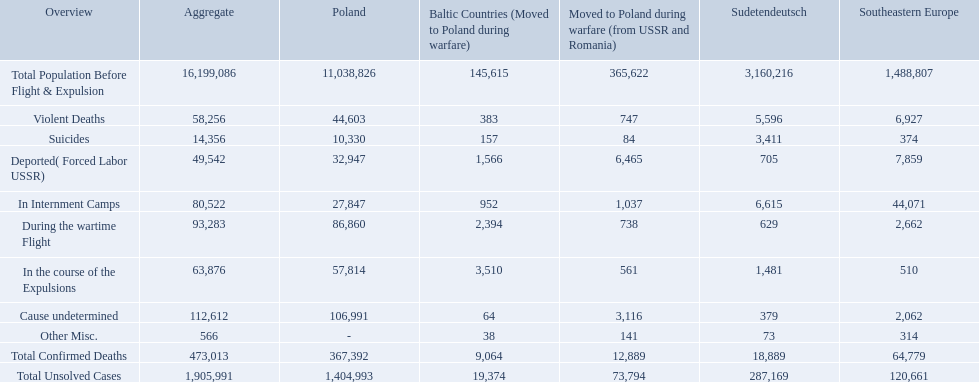What are the numbers of violent deaths across the area? 44,603, 383, 747, 5,596, 6,927. What is the total number of violent deaths of the area? 58,256. How many deaths did the baltic states have in each category? 145,615, 383, 157, 1,566, 952, 2,394, 3,510, 64, 38, 9,064, 19,374. How many cause undetermined deaths did baltic states have? 64. How many other miscellaneous deaths did baltic states have? 38. Which is higher in deaths, cause undetermined or other miscellaneous? Cause undetermined. 